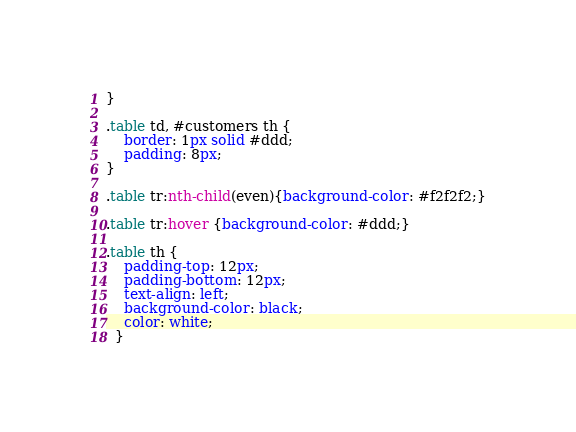Convert code to text. <code><loc_0><loc_0><loc_500><loc_500><_CSS_>}
  
.table td, #customers th {
    border: 1px solid #ddd;
    padding: 8px;
}
  
.table tr:nth-child(even){background-color: #f2f2f2;}
  
.table tr:hover {background-color: #ddd;}
  
.table th {
    padding-top: 12px;
    padding-bottom: 12px;
    text-align: left;
    background-color: black;
    color: white;
  }</code> 